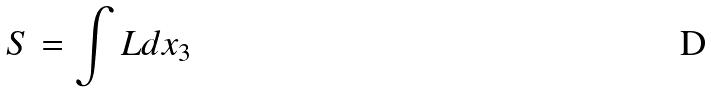<formula> <loc_0><loc_0><loc_500><loc_500>S = \int L d x _ { 3 }</formula> 